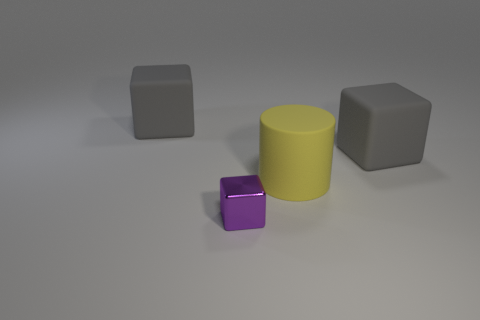Are there any small green cylinders that have the same material as the tiny purple cube?
Provide a succinct answer. No. Is there a rubber cube behind the big rubber cube in front of the big gray rubber cube to the left of the big yellow rubber cylinder?
Give a very brief answer. Yes. There is a yellow rubber thing; are there any big gray rubber blocks left of it?
Your answer should be compact. Yes. What number of small things are either matte cylinders or gray things?
Offer a very short reply. 0. Is the material of the gray block that is right of the small purple cube the same as the large yellow thing?
Your response must be concise. Yes. What is the shape of the gray thing to the right of the large gray object left of the large rubber object on the right side of the big rubber cylinder?
Offer a very short reply. Cube. How many purple things are either small objects or big cubes?
Give a very brief answer. 1. Are there an equal number of gray blocks that are right of the big yellow cylinder and things left of the shiny cube?
Offer a very short reply. Yes. There is a gray thing that is on the right side of the purple shiny object; is it the same shape as the yellow matte thing right of the tiny purple cube?
Your response must be concise. No. Are there any other things that have the same shape as the purple thing?
Provide a short and direct response. Yes. 